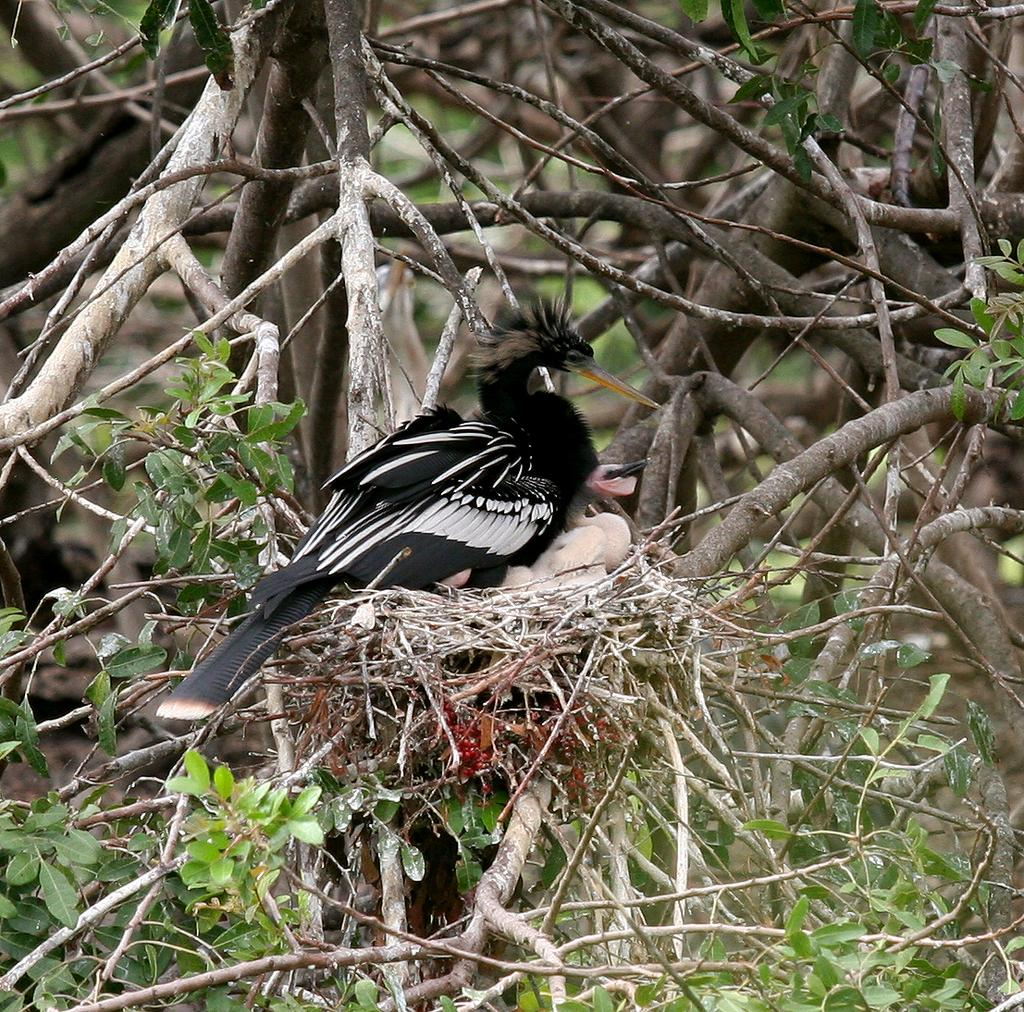What type of animals can be seen in the image? There are birds in the image. Where are the birds located? The birds are on a nest. What is the nest situated on? The nest is on a tree. What direction are the birds facing in the image? The provided facts do not mention the direction the birds are facing, so it cannot be determined from the image. 